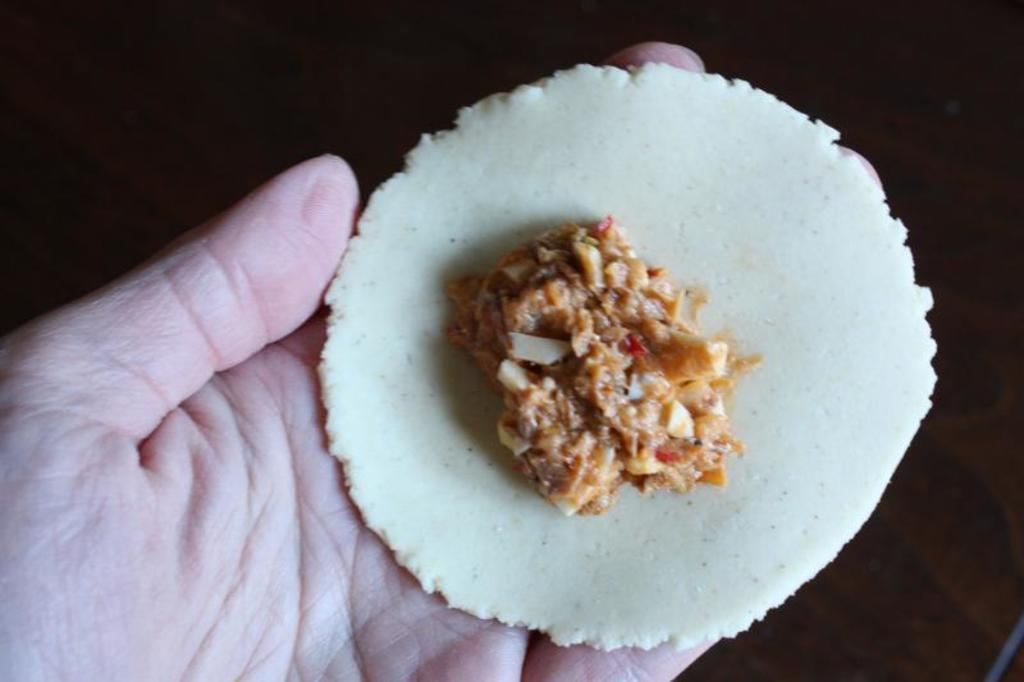What is the main subject of the image? There is a person in the image. What is the person doing in the image? The person is holding a food item. What type of land can be seen in the image? There is no land visible in the image, as it only features a person holding a food item. Can you tell me how many snails are present in the image? There are no snails present in the image. 